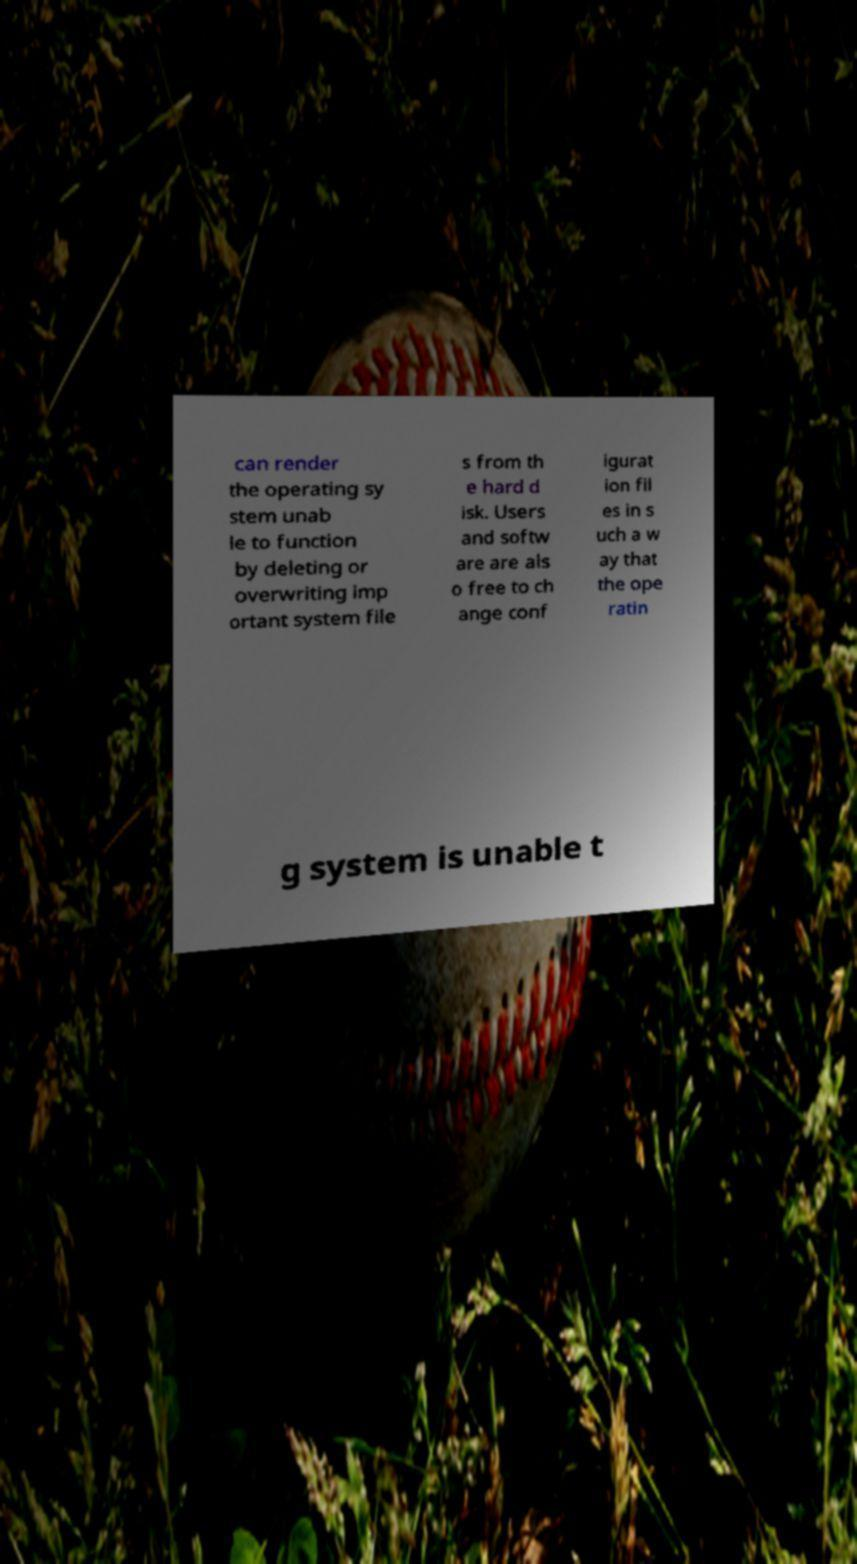Can you read and provide the text displayed in the image?This photo seems to have some interesting text. Can you extract and type it out for me? can render the operating sy stem unab le to function by deleting or overwriting imp ortant system file s from th e hard d isk. Users and softw are are als o free to ch ange conf igurat ion fil es in s uch a w ay that the ope ratin g system is unable t 